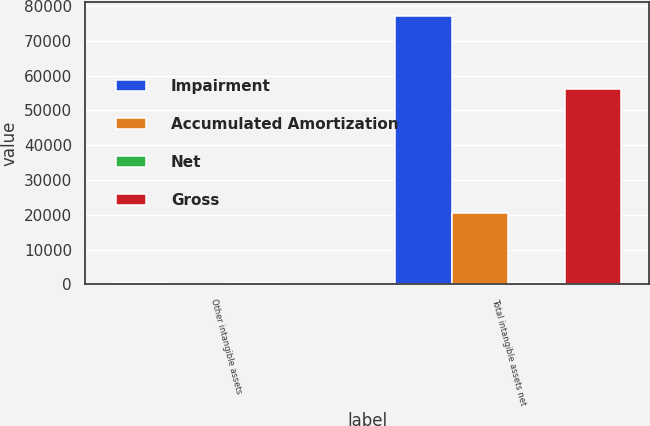Convert chart to OTSL. <chart><loc_0><loc_0><loc_500><loc_500><stacked_bar_chart><ecel><fcel>Other intangible assets<fcel>Total intangible assets net<nl><fcel>Impairment<fcel>500<fcel>77188<nl><fcel>Accumulated Amortization<fcel>172<fcel>20673<nl><fcel>Net<fcel>291<fcel>291<nl><fcel>Gross<fcel>37<fcel>56224<nl></chart> 